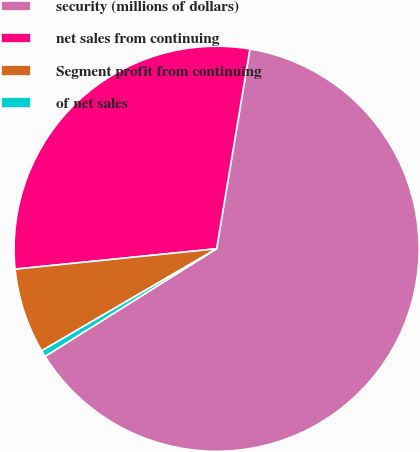Convert chart to OTSL. <chart><loc_0><loc_0><loc_500><loc_500><pie_chart><fcel>security (millions of dollars)<fcel>net sales from continuing<fcel>Segment profit from continuing<fcel>of net sales<nl><fcel>63.45%<fcel>29.24%<fcel>6.8%<fcel>0.51%<nl></chart> 